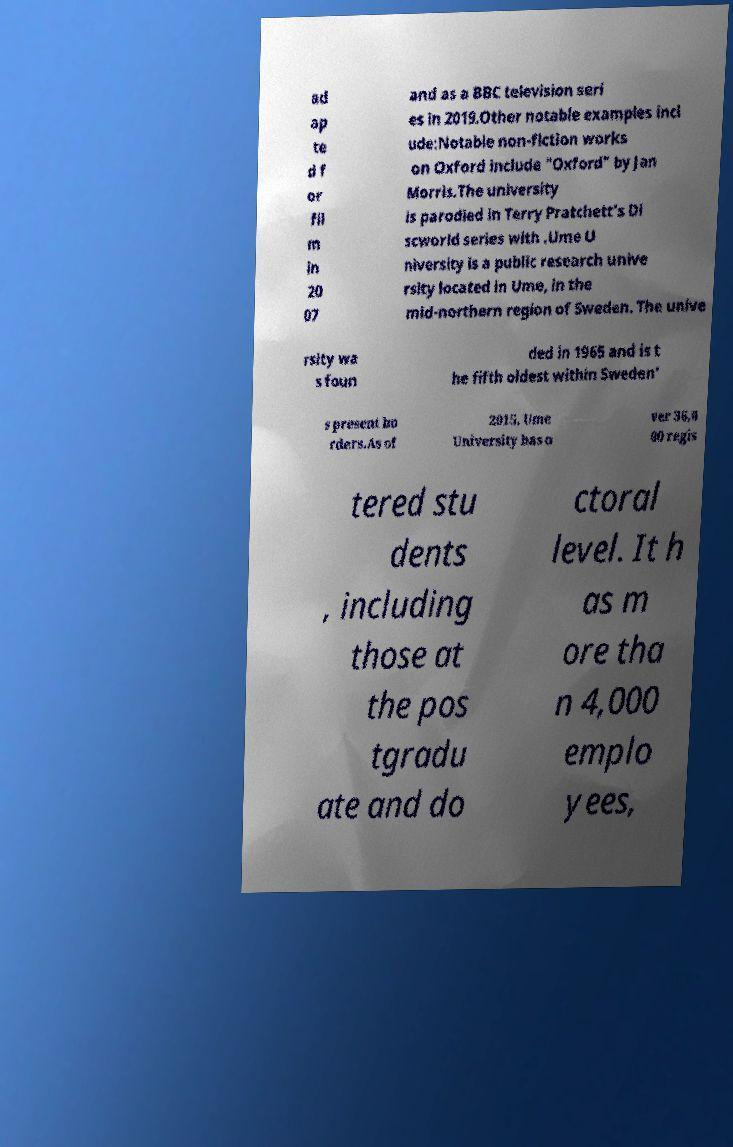Please read and relay the text visible in this image. What does it say? ad ap te d f or fil m in 20 07 and as a BBC television seri es in 2019.Other notable examples incl ude:Notable non-fiction works on Oxford include "Oxford" by Jan Morris.The university is parodied in Terry Pratchett's Di scworld series with .Ume U niversity is a public research unive rsity located in Ume, in the mid-northern region of Sweden. The unive rsity wa s foun ded in 1965 and is t he fifth oldest within Sweden' s present bo rders.As of 2015, Ume University has o ver 36,0 00 regis tered stu dents , including those at the pos tgradu ate and do ctoral level. It h as m ore tha n 4,000 emplo yees, 